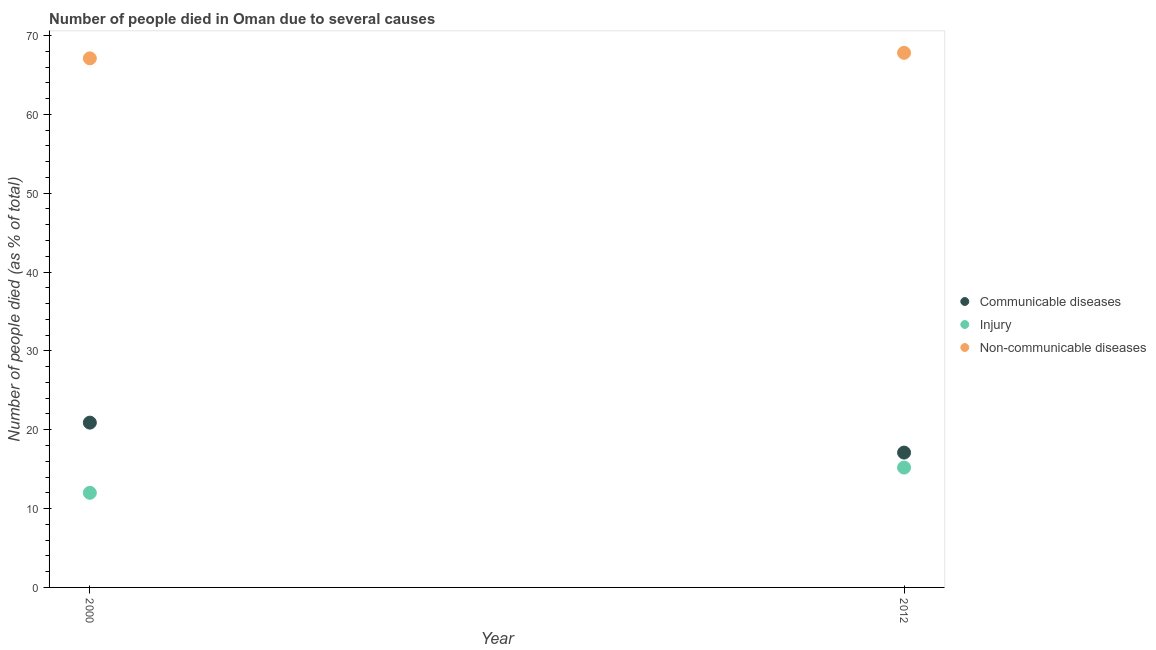How many different coloured dotlines are there?
Your answer should be compact. 3. What is the number of people who died of communicable diseases in 2012?
Offer a very short reply. 17.1. Across all years, what is the minimum number of people who dies of non-communicable diseases?
Ensure brevity in your answer.  67.1. In which year was the number of people who died of communicable diseases maximum?
Give a very brief answer. 2000. What is the total number of people who dies of non-communicable diseases in the graph?
Offer a very short reply. 134.9. What is the difference between the number of people who dies of non-communicable diseases in 2000 and that in 2012?
Your answer should be very brief. -0.7. What is the difference between the number of people who died of communicable diseases in 2012 and the number of people who died of injury in 2000?
Offer a very short reply. 5.1. What is the average number of people who dies of non-communicable diseases per year?
Ensure brevity in your answer.  67.45. In the year 2000, what is the difference between the number of people who dies of non-communicable diseases and number of people who died of communicable diseases?
Offer a very short reply. 46.2. What is the ratio of the number of people who died of communicable diseases in 2000 to that in 2012?
Provide a short and direct response. 1.22. Is the number of people who died of communicable diseases in 2000 less than that in 2012?
Your answer should be very brief. No. In how many years, is the number of people who died of injury greater than the average number of people who died of injury taken over all years?
Your response must be concise. 1. Is it the case that in every year, the sum of the number of people who died of communicable diseases and number of people who died of injury is greater than the number of people who dies of non-communicable diseases?
Provide a succinct answer. No. Does the number of people who dies of non-communicable diseases monotonically increase over the years?
Your answer should be very brief. Yes. Is the number of people who dies of non-communicable diseases strictly less than the number of people who died of communicable diseases over the years?
Your response must be concise. No. How many dotlines are there?
Keep it short and to the point. 3. What is the difference between two consecutive major ticks on the Y-axis?
Provide a short and direct response. 10. How are the legend labels stacked?
Your answer should be compact. Vertical. What is the title of the graph?
Provide a succinct answer. Number of people died in Oman due to several causes. What is the label or title of the Y-axis?
Give a very brief answer. Number of people died (as % of total). What is the Number of people died (as % of total) in Communicable diseases in 2000?
Give a very brief answer. 20.9. What is the Number of people died (as % of total) of Injury in 2000?
Make the answer very short. 12. What is the Number of people died (as % of total) in Non-communicable diseases in 2000?
Provide a short and direct response. 67.1. What is the Number of people died (as % of total) in Communicable diseases in 2012?
Your answer should be compact. 17.1. What is the Number of people died (as % of total) in Injury in 2012?
Ensure brevity in your answer.  15.2. What is the Number of people died (as % of total) in Non-communicable diseases in 2012?
Your response must be concise. 67.8. Across all years, what is the maximum Number of people died (as % of total) in Communicable diseases?
Your answer should be very brief. 20.9. Across all years, what is the maximum Number of people died (as % of total) of Injury?
Ensure brevity in your answer.  15.2. Across all years, what is the maximum Number of people died (as % of total) in Non-communicable diseases?
Offer a terse response. 67.8. Across all years, what is the minimum Number of people died (as % of total) of Communicable diseases?
Make the answer very short. 17.1. Across all years, what is the minimum Number of people died (as % of total) of Non-communicable diseases?
Your answer should be very brief. 67.1. What is the total Number of people died (as % of total) of Communicable diseases in the graph?
Ensure brevity in your answer.  38. What is the total Number of people died (as % of total) in Injury in the graph?
Keep it short and to the point. 27.2. What is the total Number of people died (as % of total) of Non-communicable diseases in the graph?
Your answer should be compact. 134.9. What is the difference between the Number of people died (as % of total) in Injury in 2000 and that in 2012?
Offer a terse response. -3.2. What is the difference between the Number of people died (as % of total) in Communicable diseases in 2000 and the Number of people died (as % of total) in Non-communicable diseases in 2012?
Ensure brevity in your answer.  -46.9. What is the difference between the Number of people died (as % of total) of Injury in 2000 and the Number of people died (as % of total) of Non-communicable diseases in 2012?
Your response must be concise. -55.8. What is the average Number of people died (as % of total) in Injury per year?
Provide a short and direct response. 13.6. What is the average Number of people died (as % of total) of Non-communicable diseases per year?
Make the answer very short. 67.45. In the year 2000, what is the difference between the Number of people died (as % of total) in Communicable diseases and Number of people died (as % of total) in Non-communicable diseases?
Keep it short and to the point. -46.2. In the year 2000, what is the difference between the Number of people died (as % of total) of Injury and Number of people died (as % of total) of Non-communicable diseases?
Your response must be concise. -55.1. In the year 2012, what is the difference between the Number of people died (as % of total) of Communicable diseases and Number of people died (as % of total) of Injury?
Make the answer very short. 1.9. In the year 2012, what is the difference between the Number of people died (as % of total) of Communicable diseases and Number of people died (as % of total) of Non-communicable diseases?
Offer a terse response. -50.7. In the year 2012, what is the difference between the Number of people died (as % of total) in Injury and Number of people died (as % of total) in Non-communicable diseases?
Give a very brief answer. -52.6. What is the ratio of the Number of people died (as % of total) in Communicable diseases in 2000 to that in 2012?
Your response must be concise. 1.22. What is the ratio of the Number of people died (as % of total) in Injury in 2000 to that in 2012?
Your answer should be compact. 0.79. What is the ratio of the Number of people died (as % of total) of Non-communicable diseases in 2000 to that in 2012?
Your answer should be compact. 0.99. What is the difference between the highest and the second highest Number of people died (as % of total) in Injury?
Offer a very short reply. 3.2. What is the difference between the highest and the lowest Number of people died (as % of total) of Injury?
Provide a short and direct response. 3.2. 